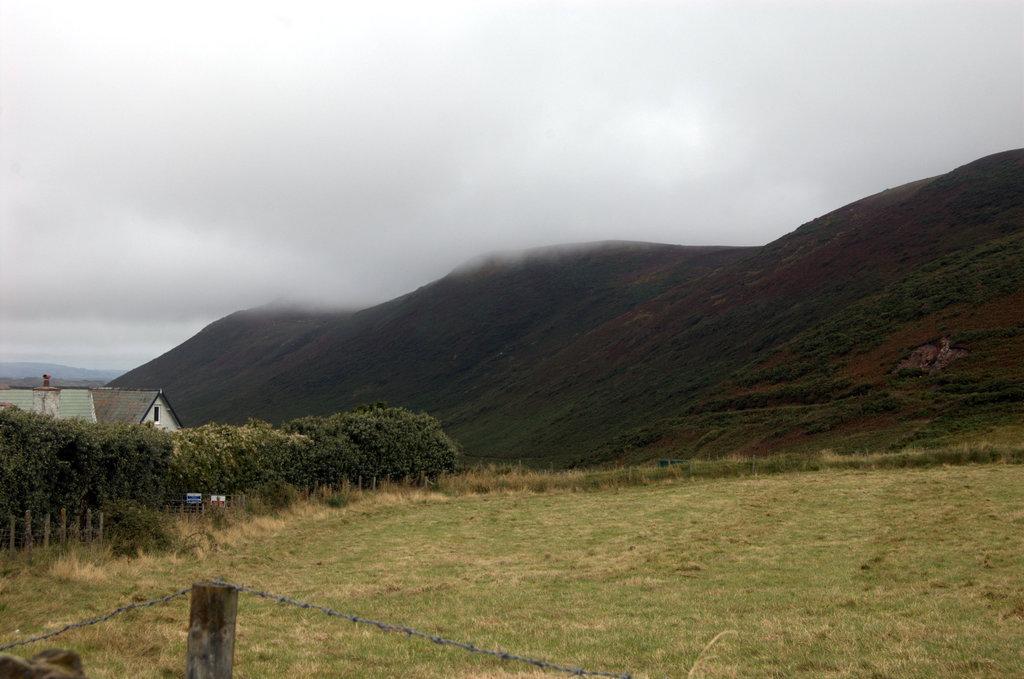Describe this image in one or two sentences. In this image, we can see trees, plants, grass, poles, boards, houses, hills and fog. At the bottom, we can see fencing wire. Background there is the sky. 